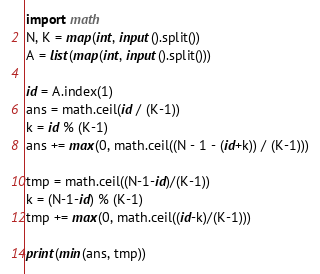Convert code to text. <code><loc_0><loc_0><loc_500><loc_500><_Python_>import math
N, K = map(int, input().split())
A = list(map(int, input().split()))

id = A.index(1)
ans = math.ceil(id / (K-1))
k = id % (K-1)
ans += max(0, math.ceil((N - 1 - (id+k)) / (K-1)))

tmp = math.ceil((N-1-id)/(K-1))
k = (N-1-id) % (K-1)
tmp += max(0, math.ceil((id-k)/(K-1)))

print(min(ans, tmp))
</code> 